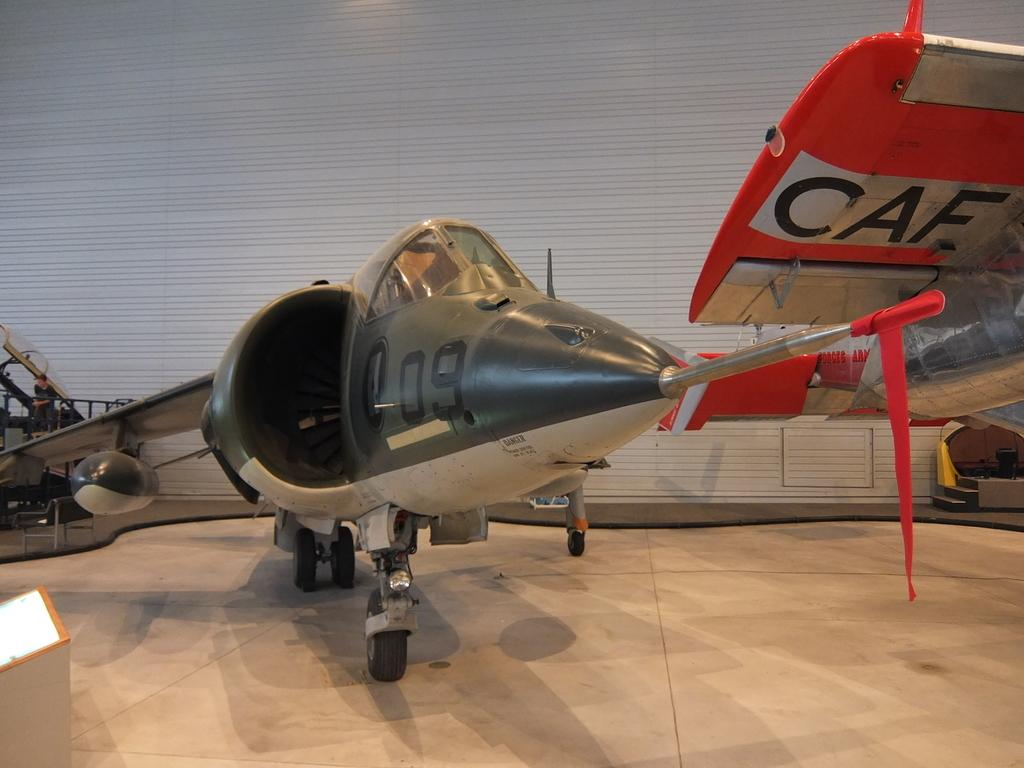<image>
Render a clear and concise summary of the photo. A green jet plane in a hangar with 09 markings near the nose 